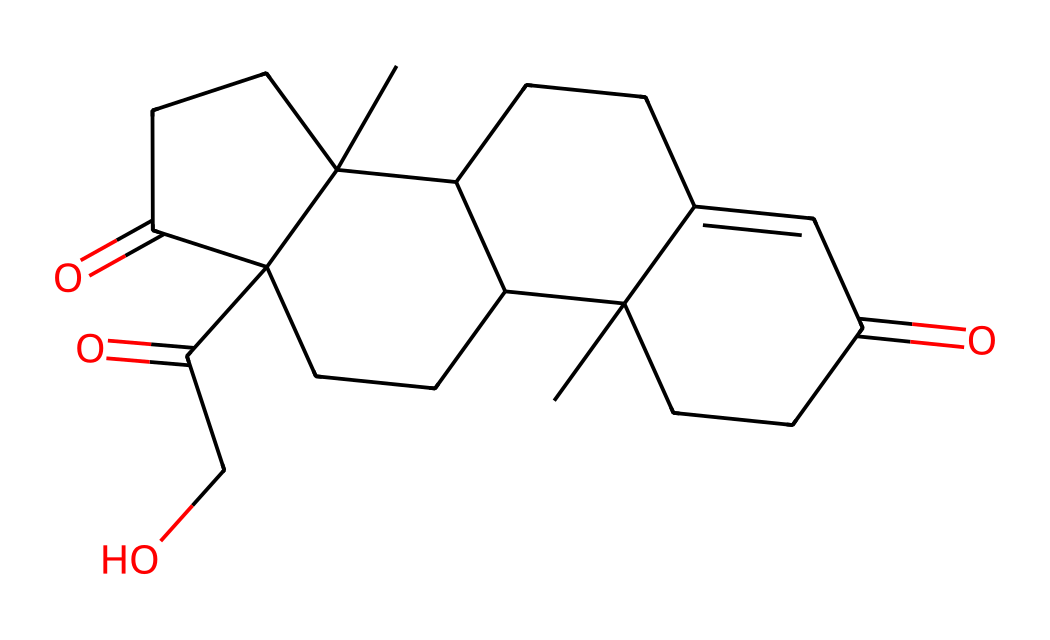What is the main functional group present in cortisol? The chemical structure shows a ketone group (indicated by C=O) and hydroxyl groups (indicated by -OH) within the molecule. The presence of carbonyl (C=O) and hydroxyl (-OH) functional groups is characteristic of steroids and indicates the role of cortisol as a hormone.
Answer: ketone How many rings are present in the cortisol structure? By examining the chemical structure, cortisol contains four fused cycloalkane rings, which is typical of steroid structures. Counting the rings visually reveals that there are four distinct connects and overlaps.
Answer: four What is the total number of carbon atoms in cortisol? Analyzing the SMILES representation, each 'C' indicates a carbon atom and we count a total of 21 'C's in the structure. Therefore, by counting each carbon in the molecular formula or visual analysis, we conclude.
Answer: twenty-one Does cortisol contain any nitrogen atoms? On inspection of the chemical structure and the SMILES representation, there are no nitrogen atoms present as there are no 'N' symbols displayed. This leads to the conclusion that cortisol is purely a steroid without amine groups.
Answer: no Which type of compound is cortisol categorized as? Cortisol is classified as a steroid due to its characteristic structure consisting of fused carbon rings and specific functional groups (ketones and hydroxyls). The molecular structure strongly indicates it belongs to this class of compounds, which is crucial in hormonal activities.
Answer: steroid What is the molecular weight of cortisol? To find the molecular weight, we can add the atomic weights of all the atoms present in the structure, with a calculated molecular weight yielding approximately 362.46 g/mol by considering the number of each type of atom stated in the chemical formula.
Answer: 362.46 